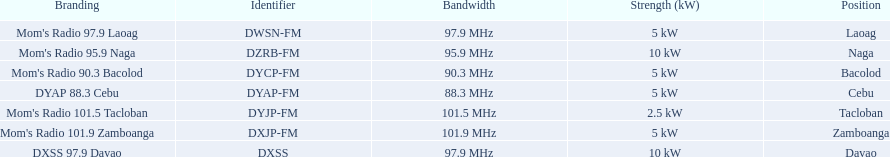Can you parse all the data within this table? {'header': ['Branding', 'Identifier', 'Bandwidth', 'Strength (kW)', 'Position'], 'rows': [["Mom's Radio 97.9 Laoag", 'DWSN-FM', '97.9\xa0MHz', '5\xa0kW', 'Laoag'], ["Mom's Radio 95.9 Naga", 'DZRB-FM', '95.9\xa0MHz', '10\xa0kW', 'Naga'], ["Mom's Radio 90.3 Bacolod", 'DYCP-FM', '90.3\xa0MHz', '5\xa0kW', 'Bacolod'], ['DYAP 88.3 Cebu', 'DYAP-FM', '88.3\xa0MHz', '5\xa0kW', 'Cebu'], ["Mom's Radio 101.5 Tacloban", 'DYJP-FM', '101.5\xa0MHz', '2.5\xa0kW', 'Tacloban'], ["Mom's Radio 101.9 Zamboanga", 'DXJP-FM', '101.9\xa0MHz', '5\xa0kW', 'Zamboanga'], ['DXSS 97.9 Davao', 'DXSS', '97.9\xa0MHz', '10\xa0kW', 'Davao']]} What is the difference in kw between naga and bacolod radio? 5 kW. 